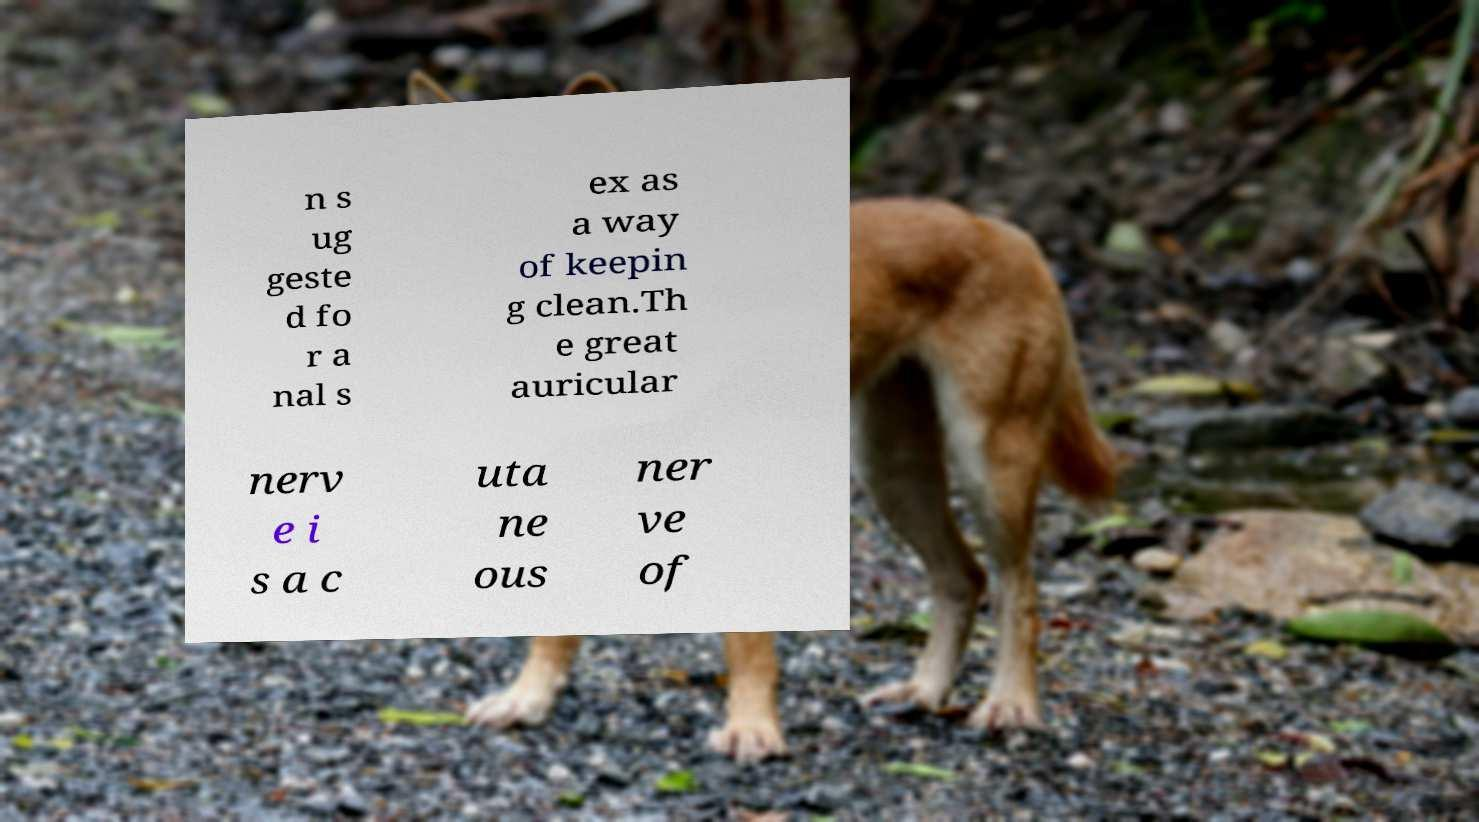There's text embedded in this image that I need extracted. Can you transcribe it verbatim? n s ug geste d fo r a nal s ex as a way of keepin g clean.Th e great auricular nerv e i s a c uta ne ous ner ve of 